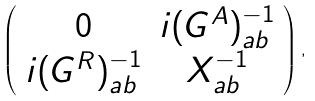Convert formula to latex. <formula><loc_0><loc_0><loc_500><loc_500>\left ( \begin{array} { c c } 0 & i ( G ^ { A } ) ^ { - 1 } _ { a b } \\ i ( G ^ { R } ) ^ { - 1 } _ { a b } & X ^ { - 1 } _ { a b } \end{array} \right ) ,</formula> 